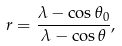Convert formula to latex. <formula><loc_0><loc_0><loc_500><loc_500>r = \frac { \lambda - \cos \theta _ { 0 } } { \lambda - \cos \theta } ,</formula> 